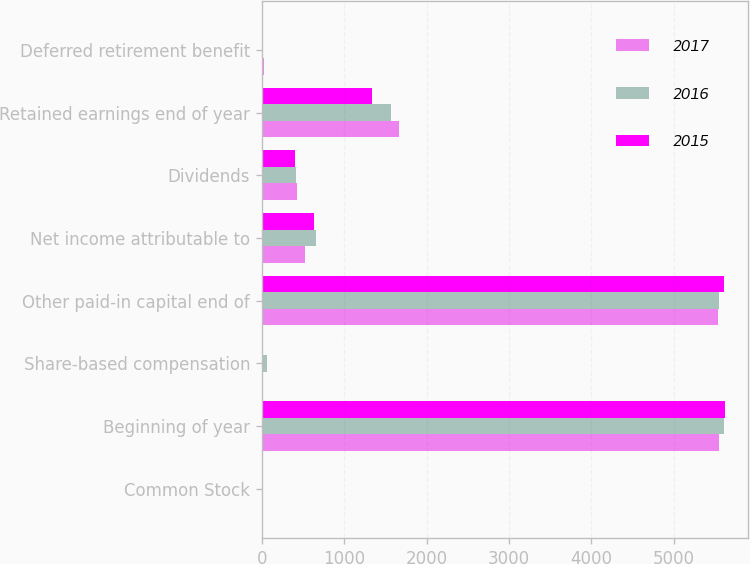Convert chart. <chart><loc_0><loc_0><loc_500><loc_500><stacked_bar_chart><ecel><fcel>Common Stock<fcel>Beginning of year<fcel>Share-based compensation<fcel>Other paid-in capital end of<fcel>Net income attributable to<fcel>Dividends<fcel>Retained earnings end of year<fcel>Deferred retirement benefit<nl><fcel>2017<fcel>2<fcel>5556<fcel>16<fcel>5540<fcel>523<fcel>431<fcel>1660<fcel>23<nl><fcel>2016<fcel>2<fcel>5616<fcel>60<fcel>5556<fcel>653<fcel>416<fcel>1568<fcel>3<nl><fcel>2015<fcel>2<fcel>5617<fcel>1<fcel>5616<fcel>630<fcel>402<fcel>1331<fcel>9<nl></chart> 